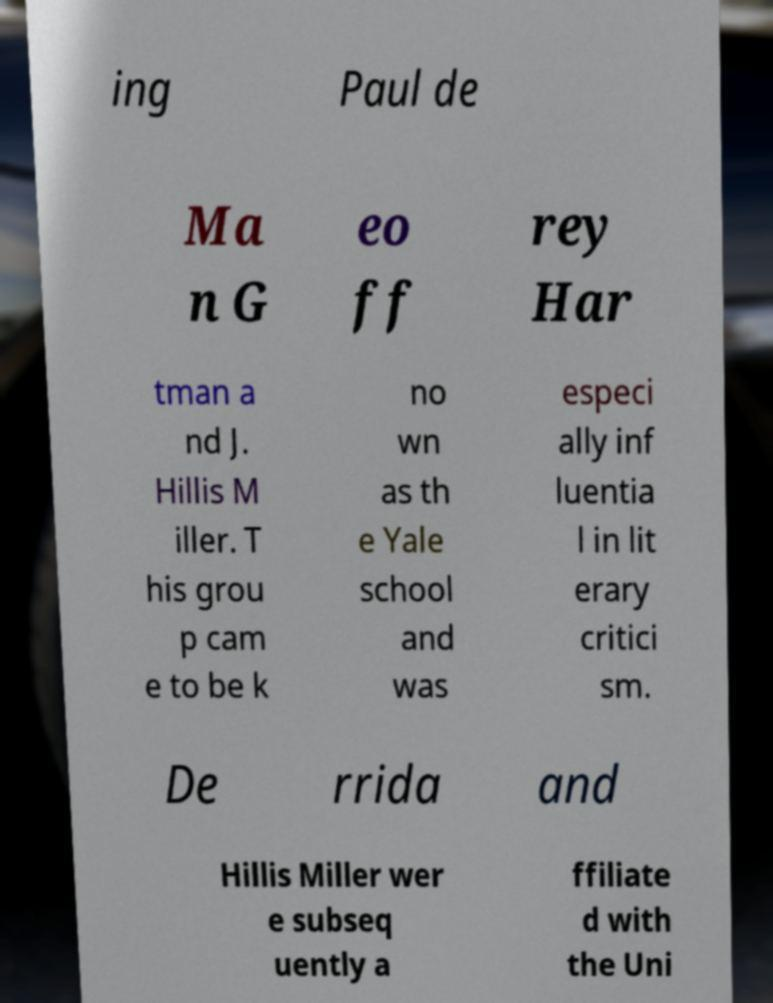Please read and relay the text visible in this image. What does it say? ing Paul de Ma n G eo ff rey Har tman a nd J. Hillis M iller. T his grou p cam e to be k no wn as th e Yale school and was especi ally inf luentia l in lit erary critici sm. De rrida and Hillis Miller wer e subseq uently a ffiliate d with the Uni 